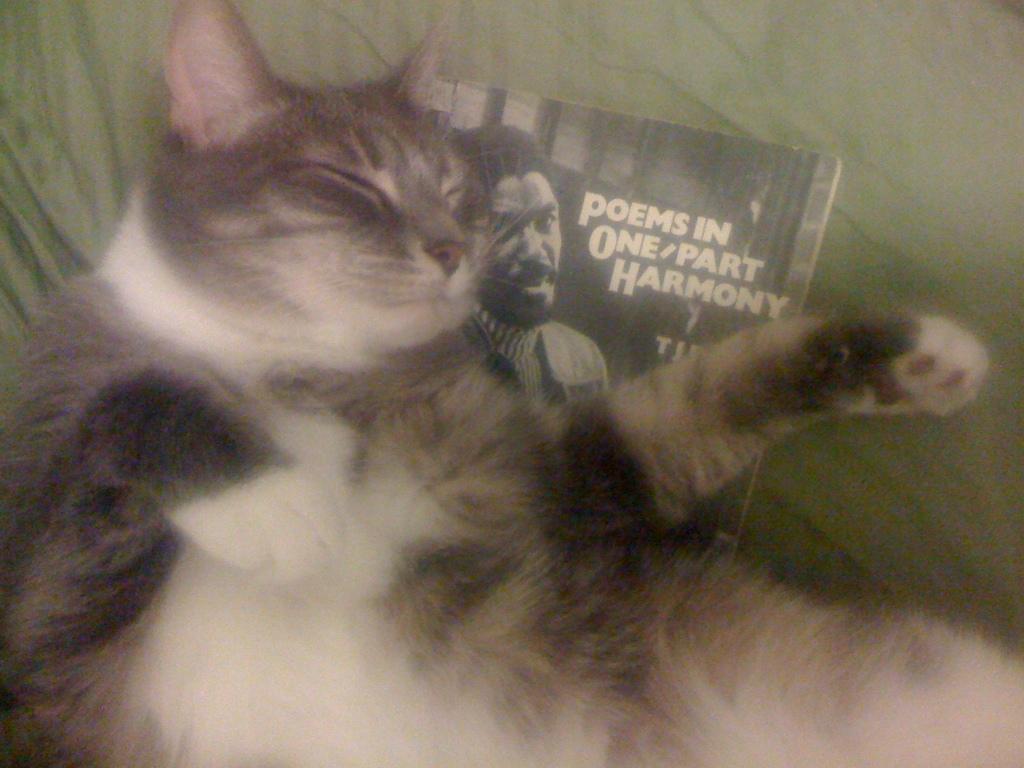Describe this image in one or two sentences. In this image we can see a cat lying on a book on which we can see a photo of a person and some text placed on a cloth. 